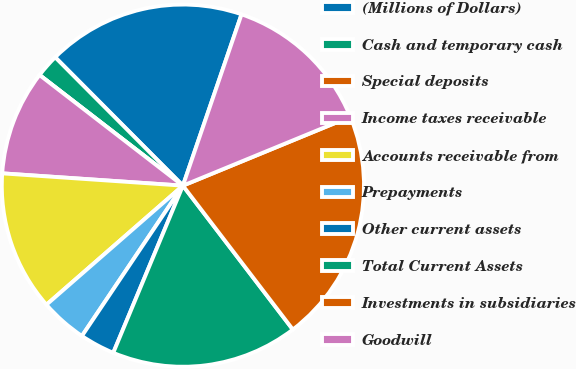Convert chart. <chart><loc_0><loc_0><loc_500><loc_500><pie_chart><fcel>(Millions of Dollars)<fcel>Cash and temporary cash<fcel>Special deposits<fcel>Income taxes receivable<fcel>Accounts receivable from<fcel>Prepayments<fcel>Other current assets<fcel>Total Current Assets<fcel>Investments in subsidiaries<fcel>Goodwill<nl><fcel>17.71%<fcel>2.08%<fcel>0.0%<fcel>9.38%<fcel>12.5%<fcel>4.17%<fcel>3.13%<fcel>16.67%<fcel>20.83%<fcel>13.54%<nl></chart> 